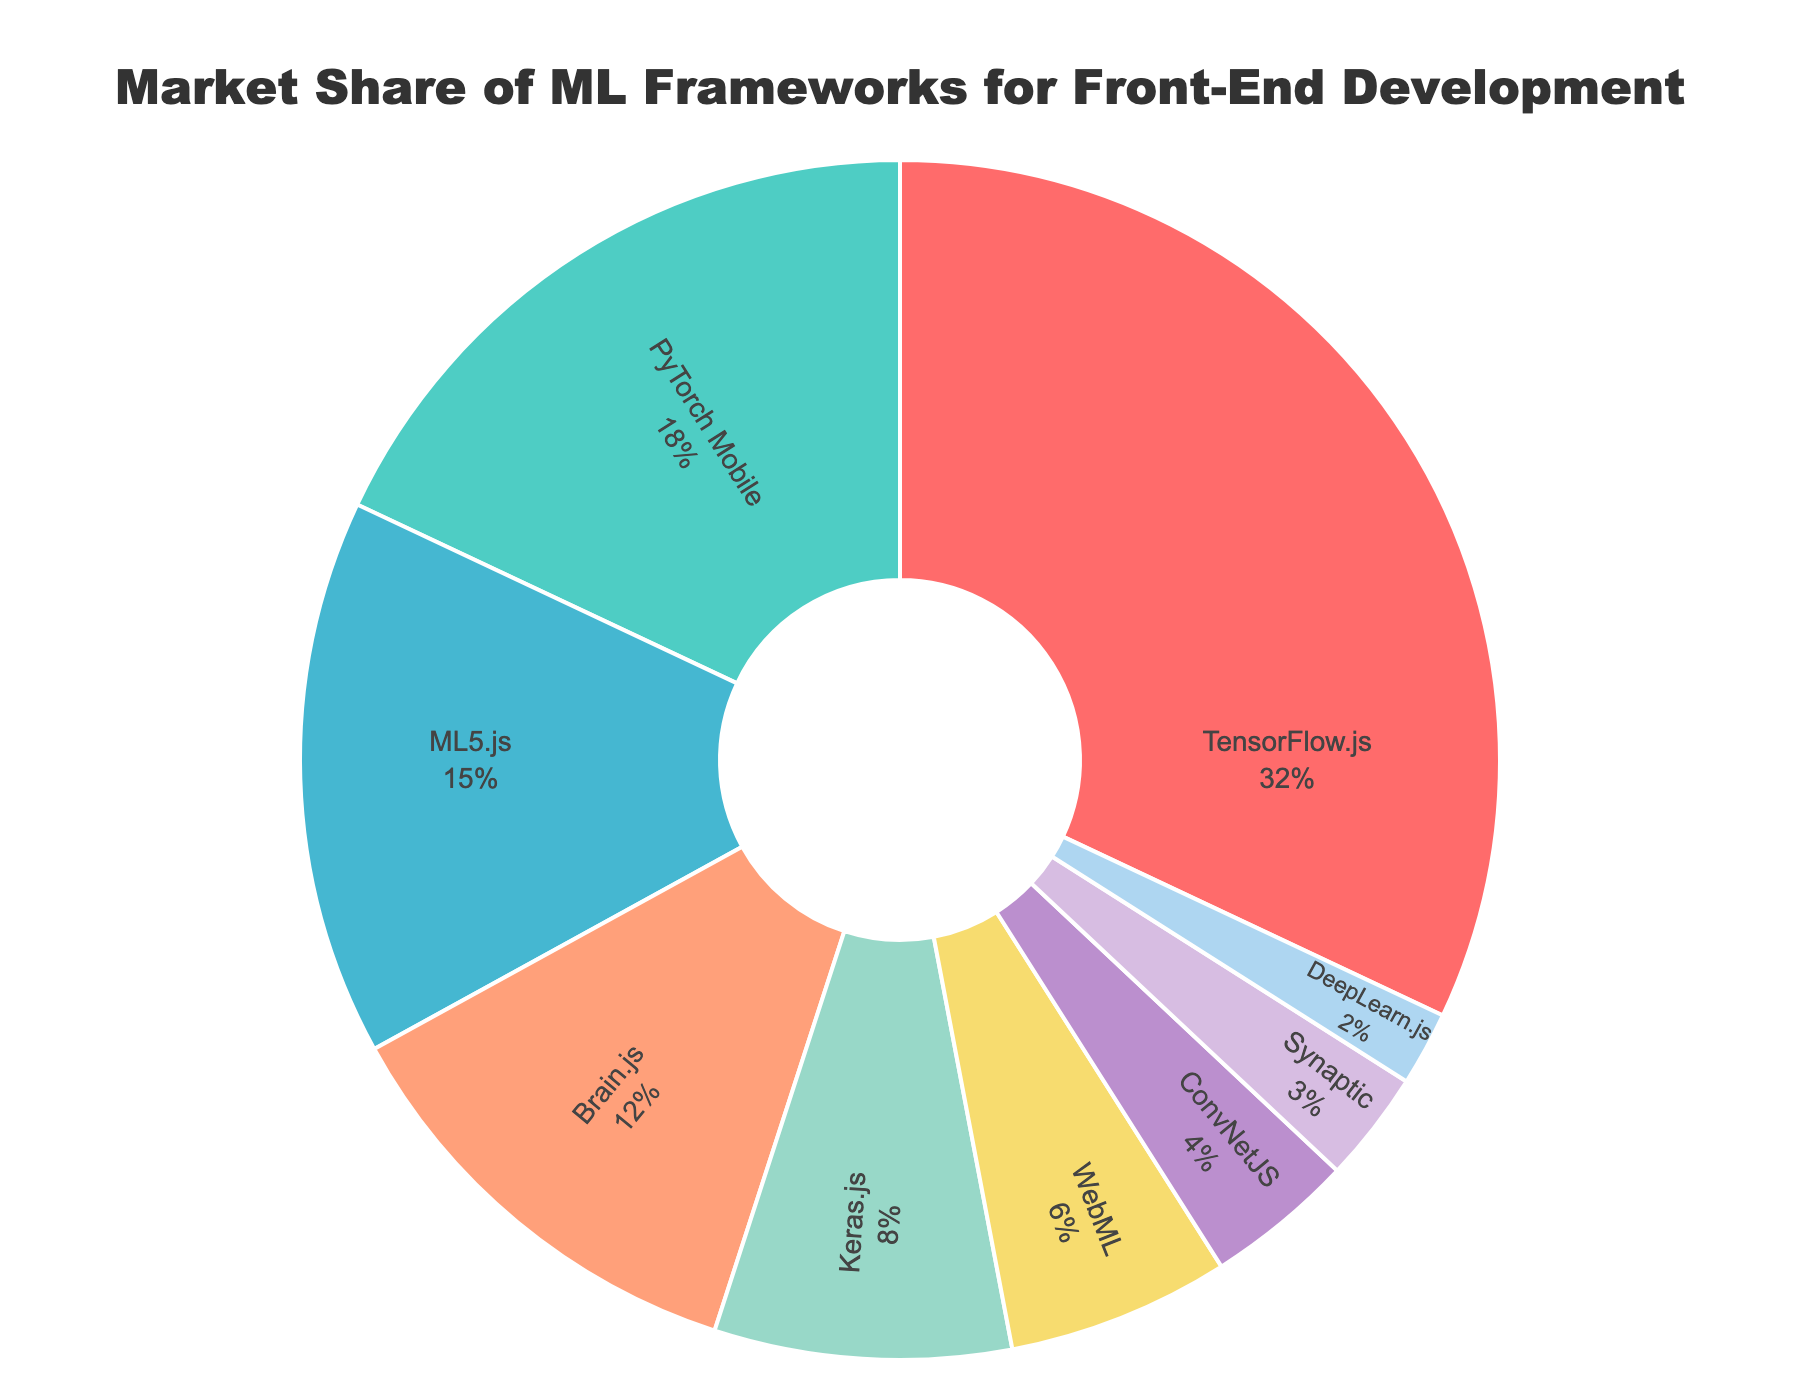Which framework has the highest market share? The framework with the highest market share is identified by the largest segment in the pie chart. In this chart, TensorFlow.js has the largest segment.
Answer: TensorFlow.js What is the total market share of Brain.js and WebML combined? Find the individual market shares of Brain.js and WebML from the pie chart. Brain.js has 12% and WebML has 6%. Adding these together, the total market share is 12% + 6% = 18%.
Answer: 18% How does the market share of PyTorch Mobile compare to ML5.js? Check the market shares of PyTorch Mobile and ML5.js from the pie chart. PyTorch Mobile has a market share of 18% and ML5.js has 15%. PyTorch Mobile's share is 3% more than ML5.js.
Answer: 3% more What is the difference in market share between the framework with the highest and lowest shares? Identify the frameworks with the highest and lowest market shares. TensorFlow.js has the highest with 32%, and DeepLearn.js has the lowest with 2%. The difference is 32% - 2% = 30%.
Answer: 30% Which framework occupies the green segment in the pie chart? Locate the green segment in the pie chart and see the corresponding framework. The framework in the green segment is PyTorch Mobile.
Answer: PyTorch Mobile What percentage of the market is covered by the three frameworks with the smallest shares? Find the market shares of the three smallest frameworks: DeepLearn.js (2%), Synaptic (3%), and ConvNetJS (4%). Sum these percentages: 2% + 3% + 4% = 9%.
Answer: 9% How does Keras.js compare visually to TensorFlow.js in the pie chart? Visually compare the segment sizes in the pie chart. TensorFlow.js' segment is much larger than Keras.js' indicating a significantly higher market share. TensorFlow.js has 32%, while Keras.js has 8%.
Answer: TensorFlow.js much larger Identify the framework with a purple segment. Look at the pie chart for the purple segment. The purple segment corresponds to the WebML framework.
Answer: WebML Are there more frameworks with a market share above or below 10%? Count the frameworks with shares above and below 10% using the pie chart. Above 10%: TensorFlow.js, PyTorch Mobile, ML5.js, Brain.js (4 frameworks). Below 10%: Keras.js, WebML, ConvNetJS, Synaptic, DeepLearn.js (5 frameworks). There are more frameworks below 10%.
Answer: Below 10% 